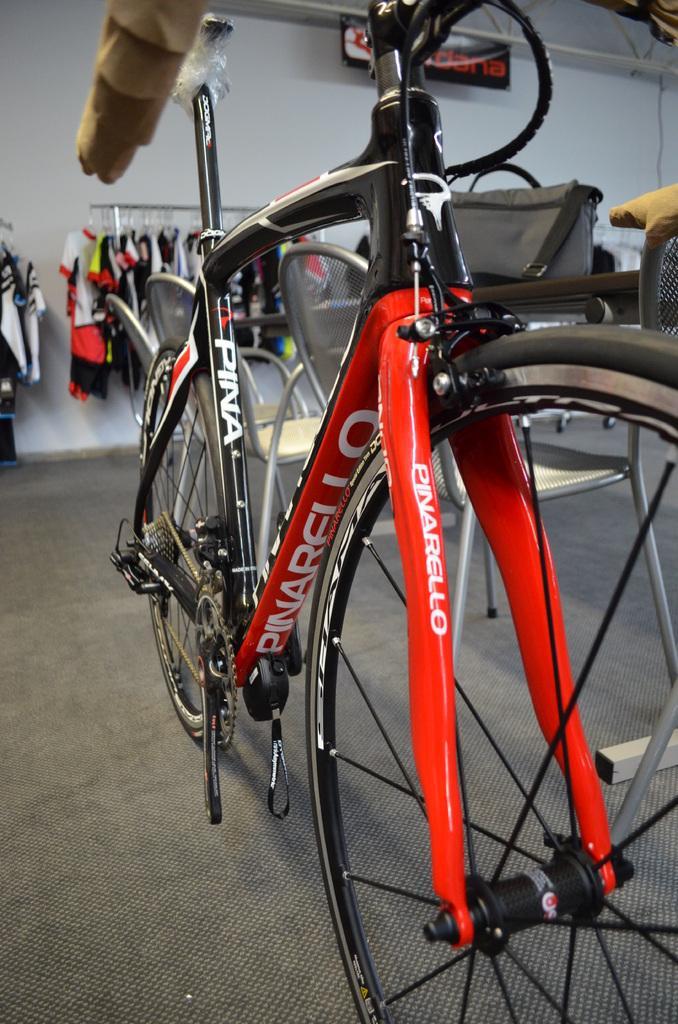Describe this image in one or two sentences. In this image, we can see a bicycle. There are a few chairs. We can see the ground. We can see some objects and clothes hanging. We can also see the wall and a poster with some text. 